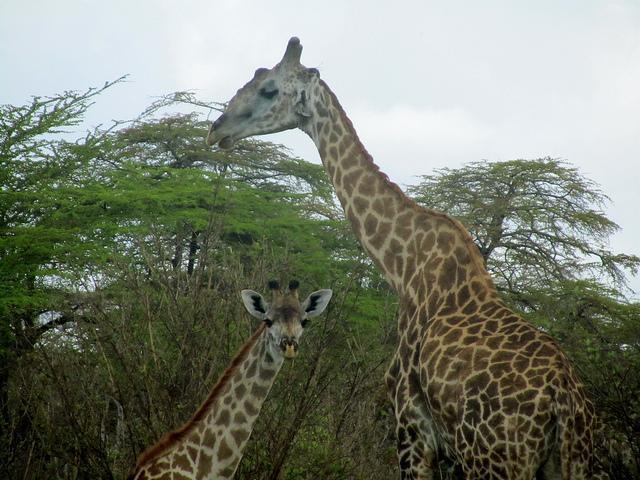How many giraffes are pictured?
Give a very brief answer. 2. How many giraffes are there?
Give a very brief answer. 2. How many giraffe are in the forest?
Give a very brief answer. 2. How many giraffes can be seen?
Give a very brief answer. 2. 